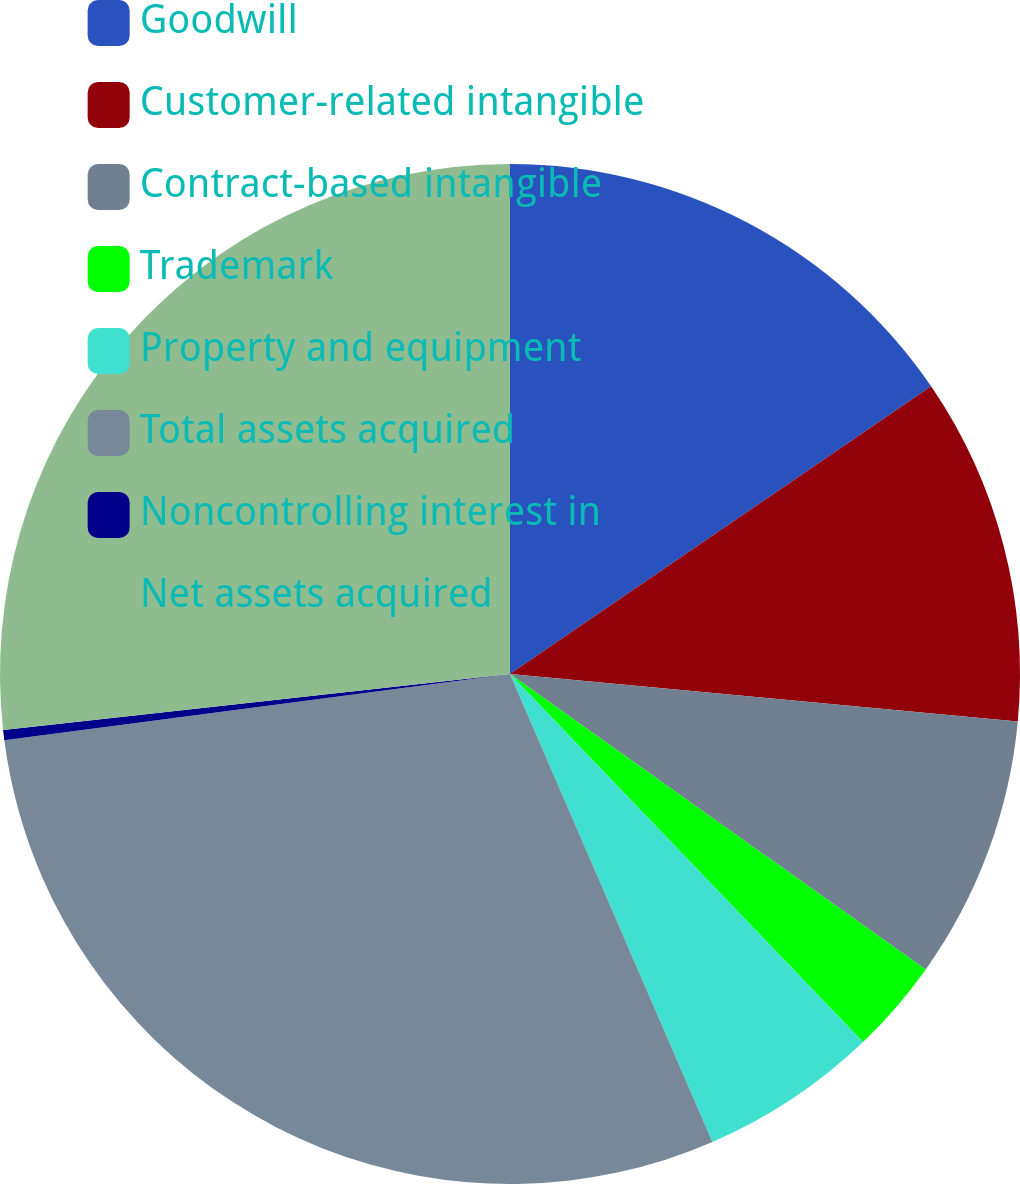<chart> <loc_0><loc_0><loc_500><loc_500><pie_chart><fcel>Goodwill<fcel>Customer-related intangible<fcel>Contract-based intangible<fcel>Trademark<fcel>Property and equipment<fcel>Total assets acquired<fcel>Noncontrolling interest in<fcel>Net assets acquired<nl><fcel>15.46%<fcel>11.02%<fcel>8.35%<fcel>3.0%<fcel>5.67%<fcel>29.42%<fcel>0.32%<fcel>26.75%<nl></chart> 